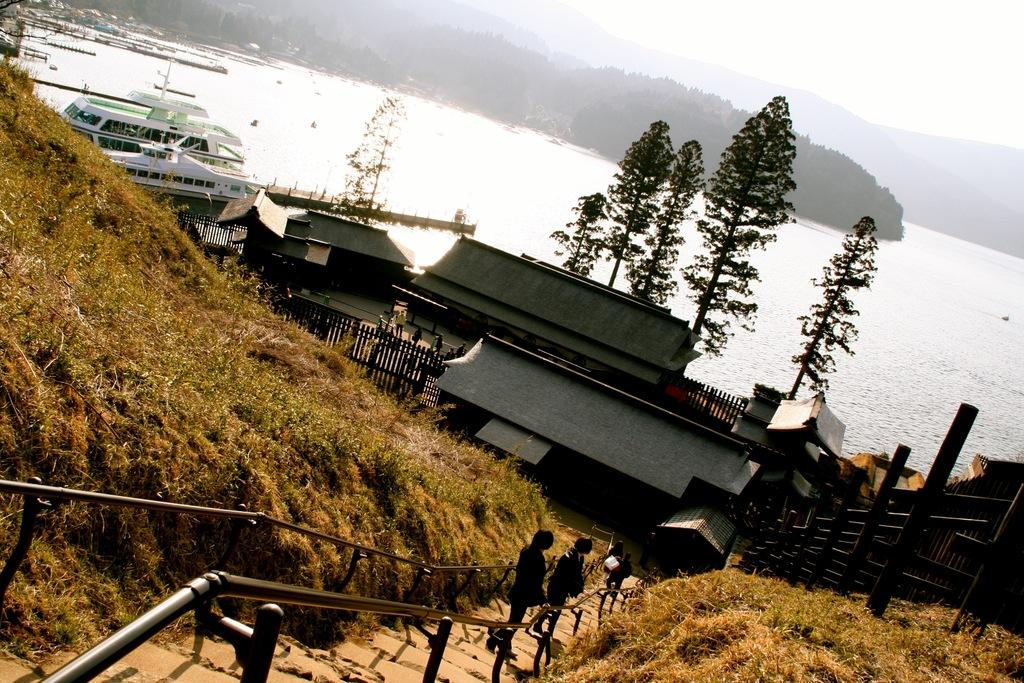How many people can be seen in the image? There are people in the image, but the exact number is not specified. What architectural feature is present in the image? There are steps and a railing in the image. What type of vegetation is visible in the image? There is grass and trees in the image. What type of structures are present in the image? There are sheds in the image. What type of barrier is present in the image? There is a fence in the image. What type of vehicles are visible in the image? There are ships in the image. What type of natural feature is visible in the image? There is water visible in the image. What type of landscape is visible in the background of the image? There are trees and hills in the background of the image, and the sky is visible as well. Where is the chain located in the image? There is no chain present in the image. Who is the friend of the person in the image? The image does not specify any individuals or their relationships, so it is not possible to determine who the friend might be. What type of button is visible on the person's clothing in the image? There are no buttons visible on anyone's clothing in the image. 